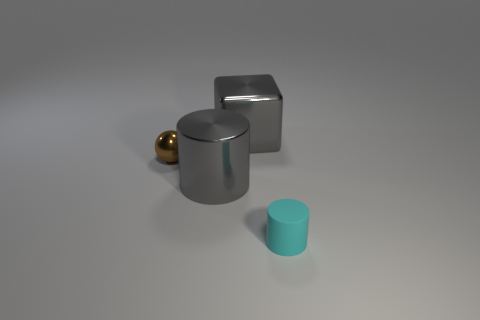Are there any other things that have the same size as the gray metal cylinder?
Your answer should be compact. Yes. How many tiny things are cyan rubber cylinders or gray rubber balls?
Offer a very short reply. 1. Is the number of big gray cylinders less than the number of things?
Your answer should be very brief. Yes. There is another thing that is the same shape as the matte object; what color is it?
Keep it short and to the point. Gray. Is there any other thing that has the same shape as the tiny shiny thing?
Offer a terse response. No. Are there more shiny things than cyan rubber objects?
Your answer should be compact. Yes. How many other things are there of the same material as the small brown object?
Provide a short and direct response. 2. What shape is the large metallic thing behind the small object on the left side of the big gray shiny thing that is behind the tiny brown metallic ball?
Ensure brevity in your answer.  Cube. Is the number of cyan rubber cylinders on the right side of the tiny cyan cylinder less than the number of large gray cylinders that are on the left side of the big cube?
Give a very brief answer. Yes. Is there a matte cylinder of the same color as the shiny ball?
Provide a succinct answer. No. 